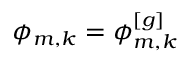Convert formula to latex. <formula><loc_0><loc_0><loc_500><loc_500>\phi _ { m , k } = \phi _ { m , k } ^ { [ g ] }</formula> 